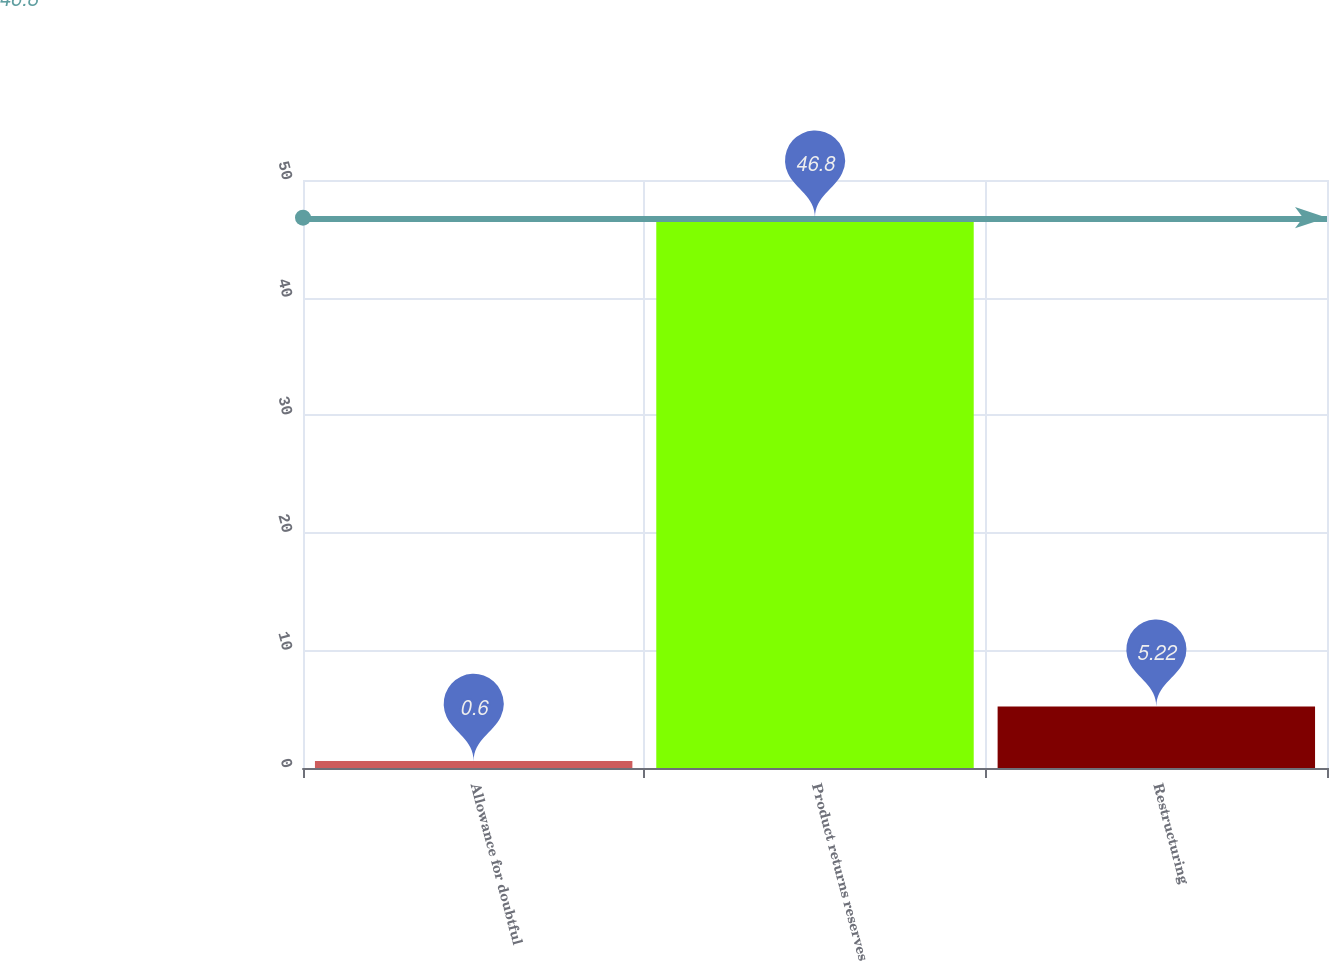<chart> <loc_0><loc_0><loc_500><loc_500><bar_chart><fcel>Allowance for doubtful<fcel>Product returns reserves<fcel>Restructuring<nl><fcel>0.6<fcel>46.8<fcel>5.22<nl></chart> 